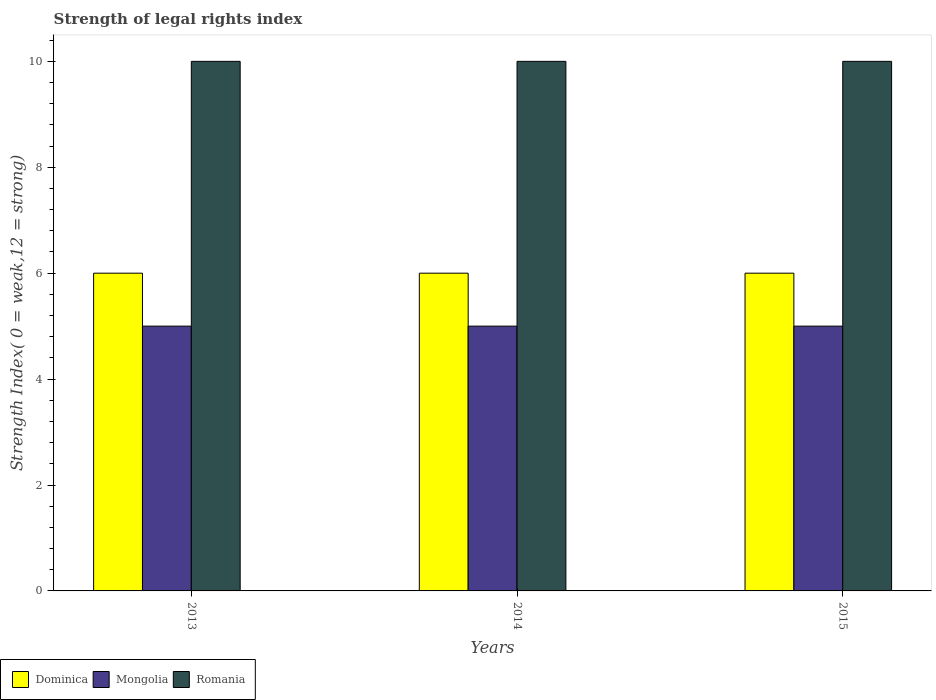Are the number of bars per tick equal to the number of legend labels?
Ensure brevity in your answer.  Yes. Are the number of bars on each tick of the X-axis equal?
Provide a short and direct response. Yes. How many bars are there on the 2nd tick from the left?
Provide a short and direct response. 3. What is the label of the 3rd group of bars from the left?
Ensure brevity in your answer.  2015. In how many cases, is the number of bars for a given year not equal to the number of legend labels?
Your response must be concise. 0. What is the strength index in Mongolia in 2015?
Give a very brief answer. 5. Across all years, what is the maximum strength index in Dominica?
Provide a succinct answer. 6. Across all years, what is the minimum strength index in Romania?
Your answer should be very brief. 10. In which year was the strength index in Dominica maximum?
Offer a very short reply. 2013. What is the total strength index in Mongolia in the graph?
Your response must be concise. 15. What is the difference between the strength index in Dominica in 2013 and that in 2014?
Your answer should be compact. 0. What is the difference between the strength index in Mongolia in 2015 and the strength index in Romania in 2014?
Give a very brief answer. -5. In the year 2013, what is the difference between the strength index in Romania and strength index in Dominica?
Keep it short and to the point. 4. In how many years, is the strength index in Mongolia greater than 6?
Provide a short and direct response. 0. What is the difference between the highest and the lowest strength index in Dominica?
Provide a short and direct response. 0. Is the sum of the strength index in Romania in 2014 and 2015 greater than the maximum strength index in Dominica across all years?
Give a very brief answer. Yes. What does the 2nd bar from the left in 2014 represents?
Your response must be concise. Mongolia. What does the 1st bar from the right in 2013 represents?
Keep it short and to the point. Romania. Is it the case that in every year, the sum of the strength index in Mongolia and strength index in Romania is greater than the strength index in Dominica?
Keep it short and to the point. Yes. How many bars are there?
Provide a short and direct response. 9. How many years are there in the graph?
Provide a short and direct response. 3. Does the graph contain any zero values?
Keep it short and to the point. No. Does the graph contain grids?
Give a very brief answer. No. Where does the legend appear in the graph?
Your answer should be very brief. Bottom left. How are the legend labels stacked?
Offer a very short reply. Horizontal. What is the title of the graph?
Your answer should be very brief. Strength of legal rights index. Does "Bahrain" appear as one of the legend labels in the graph?
Your response must be concise. No. What is the label or title of the X-axis?
Offer a terse response. Years. What is the label or title of the Y-axis?
Make the answer very short. Strength Index( 0 = weak,12 = strong). What is the Strength Index( 0 = weak,12 = strong) in Mongolia in 2013?
Make the answer very short. 5. What is the Strength Index( 0 = weak,12 = strong) in Dominica in 2014?
Your response must be concise. 6. What is the Strength Index( 0 = weak,12 = strong) of Mongolia in 2014?
Ensure brevity in your answer.  5. What is the Strength Index( 0 = weak,12 = strong) in Dominica in 2015?
Ensure brevity in your answer.  6. What is the Strength Index( 0 = weak,12 = strong) in Mongolia in 2015?
Your answer should be compact. 5. Across all years, what is the minimum Strength Index( 0 = weak,12 = strong) in Romania?
Your answer should be very brief. 10. What is the total Strength Index( 0 = weak,12 = strong) of Dominica in the graph?
Your answer should be compact. 18. What is the total Strength Index( 0 = weak,12 = strong) of Mongolia in the graph?
Provide a short and direct response. 15. What is the total Strength Index( 0 = weak,12 = strong) of Romania in the graph?
Offer a very short reply. 30. What is the difference between the Strength Index( 0 = weak,12 = strong) of Mongolia in 2013 and that in 2014?
Make the answer very short. 0. What is the difference between the Strength Index( 0 = weak,12 = strong) in Romania in 2013 and that in 2014?
Your response must be concise. 0. What is the difference between the Strength Index( 0 = weak,12 = strong) of Dominica in 2013 and that in 2015?
Provide a succinct answer. 0. What is the difference between the Strength Index( 0 = weak,12 = strong) of Romania in 2013 and that in 2015?
Keep it short and to the point. 0. What is the difference between the Strength Index( 0 = weak,12 = strong) of Dominica in 2014 and that in 2015?
Offer a very short reply. 0. What is the difference between the Strength Index( 0 = weak,12 = strong) of Mongolia in 2014 and that in 2015?
Your answer should be very brief. 0. What is the difference between the Strength Index( 0 = weak,12 = strong) in Mongolia in 2013 and the Strength Index( 0 = weak,12 = strong) in Romania in 2014?
Give a very brief answer. -5. What is the difference between the Strength Index( 0 = weak,12 = strong) of Mongolia in 2013 and the Strength Index( 0 = weak,12 = strong) of Romania in 2015?
Your answer should be compact. -5. What is the difference between the Strength Index( 0 = weak,12 = strong) of Dominica in 2014 and the Strength Index( 0 = weak,12 = strong) of Romania in 2015?
Your response must be concise. -4. What is the difference between the Strength Index( 0 = weak,12 = strong) in Mongolia in 2014 and the Strength Index( 0 = weak,12 = strong) in Romania in 2015?
Your response must be concise. -5. What is the average Strength Index( 0 = weak,12 = strong) in Dominica per year?
Provide a short and direct response. 6. What is the average Strength Index( 0 = weak,12 = strong) in Mongolia per year?
Your response must be concise. 5. What is the average Strength Index( 0 = weak,12 = strong) in Romania per year?
Provide a short and direct response. 10. In the year 2014, what is the difference between the Strength Index( 0 = weak,12 = strong) in Dominica and Strength Index( 0 = weak,12 = strong) in Romania?
Your response must be concise. -4. In the year 2014, what is the difference between the Strength Index( 0 = weak,12 = strong) of Mongolia and Strength Index( 0 = weak,12 = strong) of Romania?
Keep it short and to the point. -5. In the year 2015, what is the difference between the Strength Index( 0 = weak,12 = strong) of Dominica and Strength Index( 0 = weak,12 = strong) of Mongolia?
Provide a succinct answer. 1. What is the ratio of the Strength Index( 0 = weak,12 = strong) in Mongolia in 2013 to that in 2014?
Ensure brevity in your answer.  1. What is the ratio of the Strength Index( 0 = weak,12 = strong) of Romania in 2013 to that in 2014?
Provide a succinct answer. 1. What is the ratio of the Strength Index( 0 = weak,12 = strong) of Dominica in 2013 to that in 2015?
Provide a succinct answer. 1. What is the ratio of the Strength Index( 0 = weak,12 = strong) in Mongolia in 2014 to that in 2015?
Offer a very short reply. 1. What is the difference between the highest and the second highest Strength Index( 0 = weak,12 = strong) in Mongolia?
Your answer should be compact. 0. What is the difference between the highest and the second highest Strength Index( 0 = weak,12 = strong) in Romania?
Your answer should be very brief. 0. What is the difference between the highest and the lowest Strength Index( 0 = weak,12 = strong) in Mongolia?
Give a very brief answer. 0. 